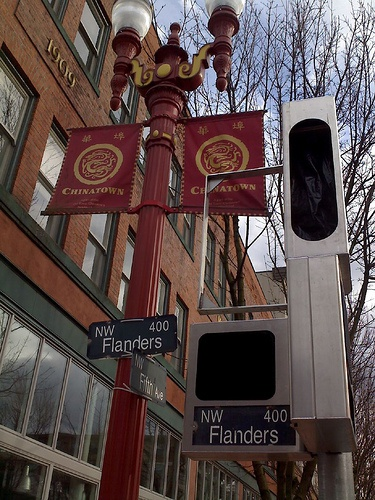Describe the objects in this image and their specific colors. I can see a traffic light in brown, black, darkgray, lightgray, and gray tones in this image. 